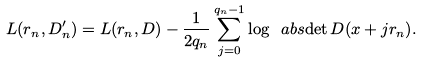<formula> <loc_0><loc_0><loc_500><loc_500>L ( r _ { n } , D _ { n } ^ { \prime } ) = L ( r _ { n } , D ) - \frac { 1 } { 2 q _ { n } } \sum _ { j = 0 } ^ { q _ { n } - 1 } \log \ a b s { \det D ( x + j r _ { n } ) } .</formula> 